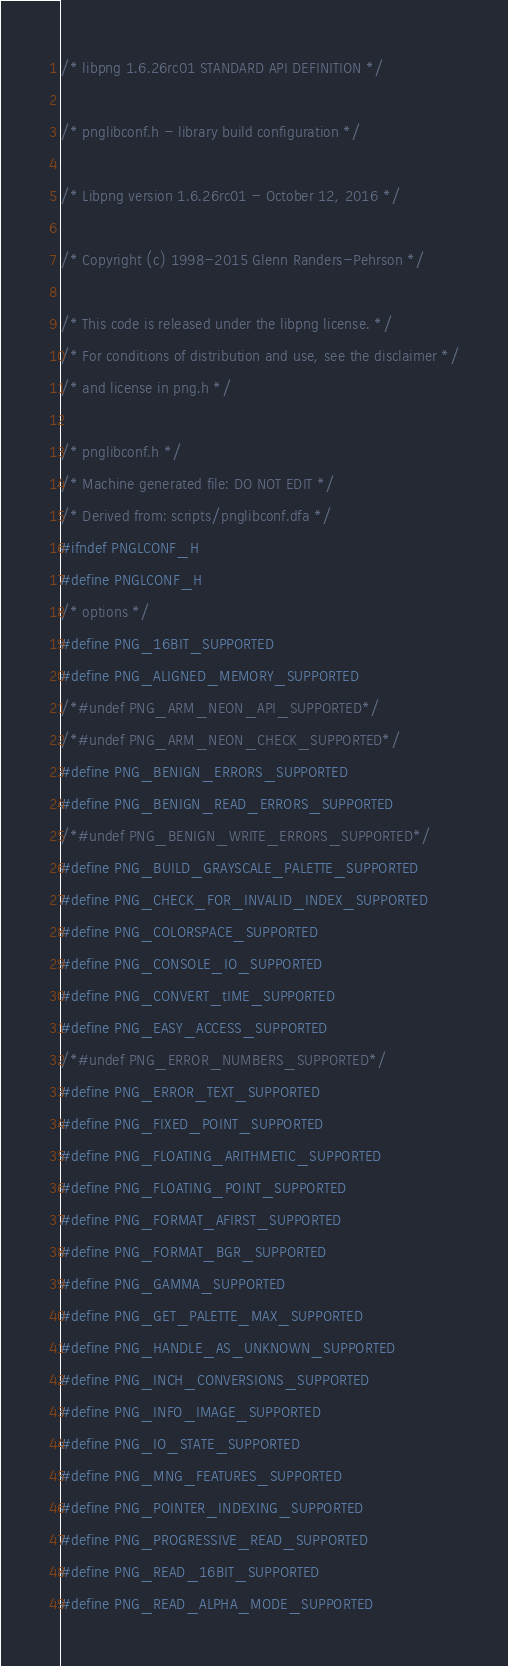Convert code to text. <code><loc_0><loc_0><loc_500><loc_500><_C_>/* libpng 1.6.26rc01 STANDARD API DEFINITION */

/* pnglibconf.h - library build configuration */

/* Libpng version 1.6.26rc01 - October 12, 2016 */

/* Copyright (c) 1998-2015 Glenn Randers-Pehrson */

/* This code is released under the libpng license. */
/* For conditions of distribution and use, see the disclaimer */
/* and license in png.h */

/* pnglibconf.h */
/* Machine generated file: DO NOT EDIT */
/* Derived from: scripts/pnglibconf.dfa */
#ifndef PNGLCONF_H
#define PNGLCONF_H
/* options */
#define PNG_16BIT_SUPPORTED
#define PNG_ALIGNED_MEMORY_SUPPORTED
/*#undef PNG_ARM_NEON_API_SUPPORTED*/
/*#undef PNG_ARM_NEON_CHECK_SUPPORTED*/
#define PNG_BENIGN_ERRORS_SUPPORTED
#define PNG_BENIGN_READ_ERRORS_SUPPORTED
/*#undef PNG_BENIGN_WRITE_ERRORS_SUPPORTED*/
#define PNG_BUILD_GRAYSCALE_PALETTE_SUPPORTED
#define PNG_CHECK_FOR_INVALID_INDEX_SUPPORTED
#define PNG_COLORSPACE_SUPPORTED
#define PNG_CONSOLE_IO_SUPPORTED
#define PNG_CONVERT_tIME_SUPPORTED
#define PNG_EASY_ACCESS_SUPPORTED
/*#undef PNG_ERROR_NUMBERS_SUPPORTED*/
#define PNG_ERROR_TEXT_SUPPORTED
#define PNG_FIXED_POINT_SUPPORTED
#define PNG_FLOATING_ARITHMETIC_SUPPORTED
#define PNG_FLOATING_POINT_SUPPORTED
#define PNG_FORMAT_AFIRST_SUPPORTED
#define PNG_FORMAT_BGR_SUPPORTED
#define PNG_GAMMA_SUPPORTED
#define PNG_GET_PALETTE_MAX_SUPPORTED
#define PNG_HANDLE_AS_UNKNOWN_SUPPORTED
#define PNG_INCH_CONVERSIONS_SUPPORTED
#define PNG_INFO_IMAGE_SUPPORTED
#define PNG_IO_STATE_SUPPORTED
#define PNG_MNG_FEATURES_SUPPORTED
#define PNG_POINTER_INDEXING_SUPPORTED
#define PNG_PROGRESSIVE_READ_SUPPORTED
#define PNG_READ_16BIT_SUPPORTED
#define PNG_READ_ALPHA_MODE_SUPPORTED</code> 